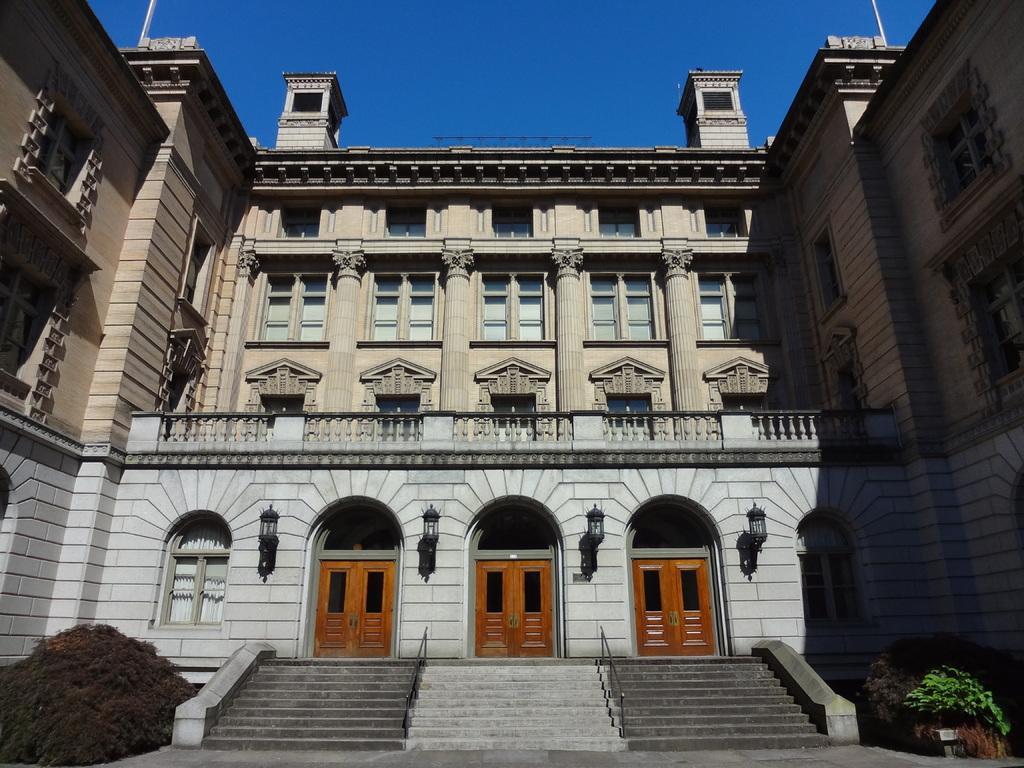Please provide a concise description of this image. In this image I can see a building in gray and brown color, in front I can see two doors in brown color, few lights, plants in green color, background the sky is in blue color. 